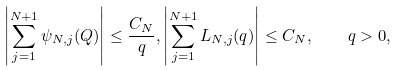<formula> <loc_0><loc_0><loc_500><loc_500>\left | \sum _ { j = 1 } ^ { N + 1 } \psi _ { N , j } ( Q ) \right | \leq \frac { C _ { N } } { q } , \left | \sum _ { j = 1 } ^ { N + 1 } L _ { N , j } ( q ) \right | \leq C _ { N } , \quad q > 0 ,</formula> 